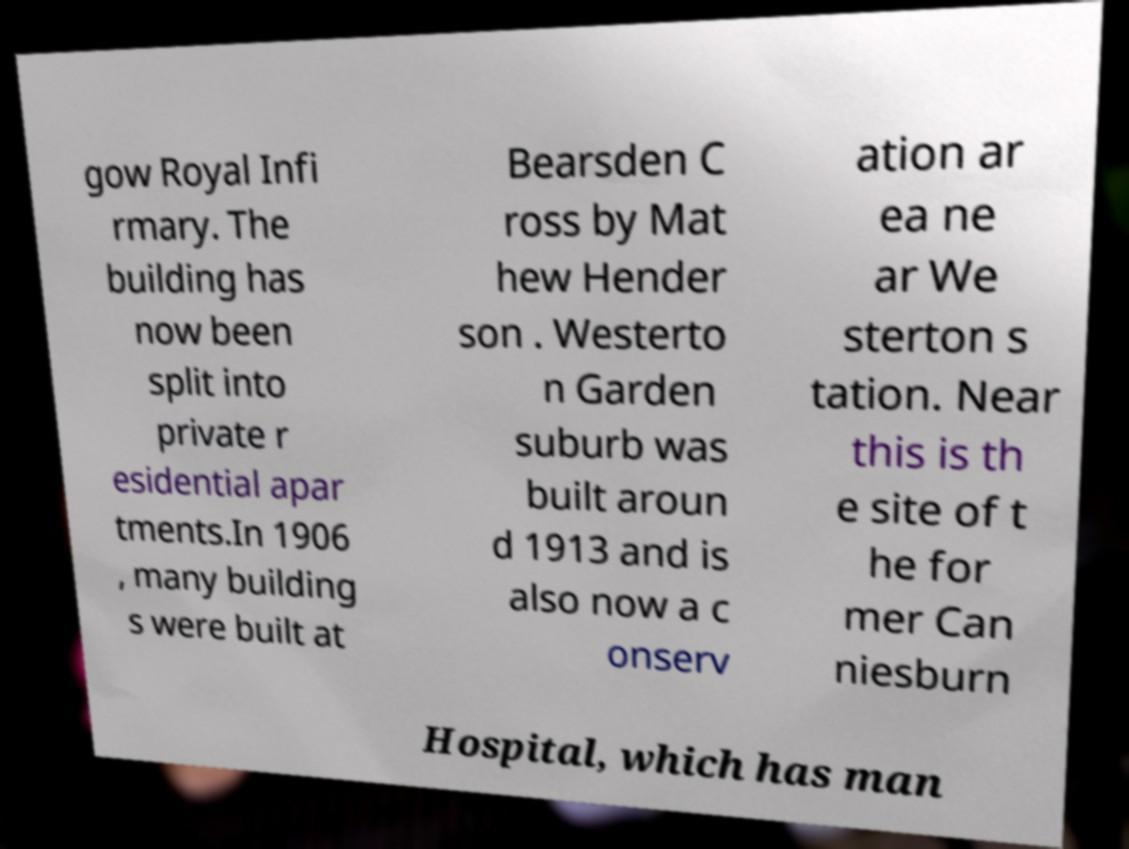There's text embedded in this image that I need extracted. Can you transcribe it verbatim? gow Royal Infi rmary. The building has now been split into private r esidential apar tments.In 1906 , many building s were built at Bearsden C ross by Mat hew Hender son . Westerto n Garden suburb was built aroun d 1913 and is also now a c onserv ation ar ea ne ar We sterton s tation. Near this is th e site of t he for mer Can niesburn Hospital, which has man 